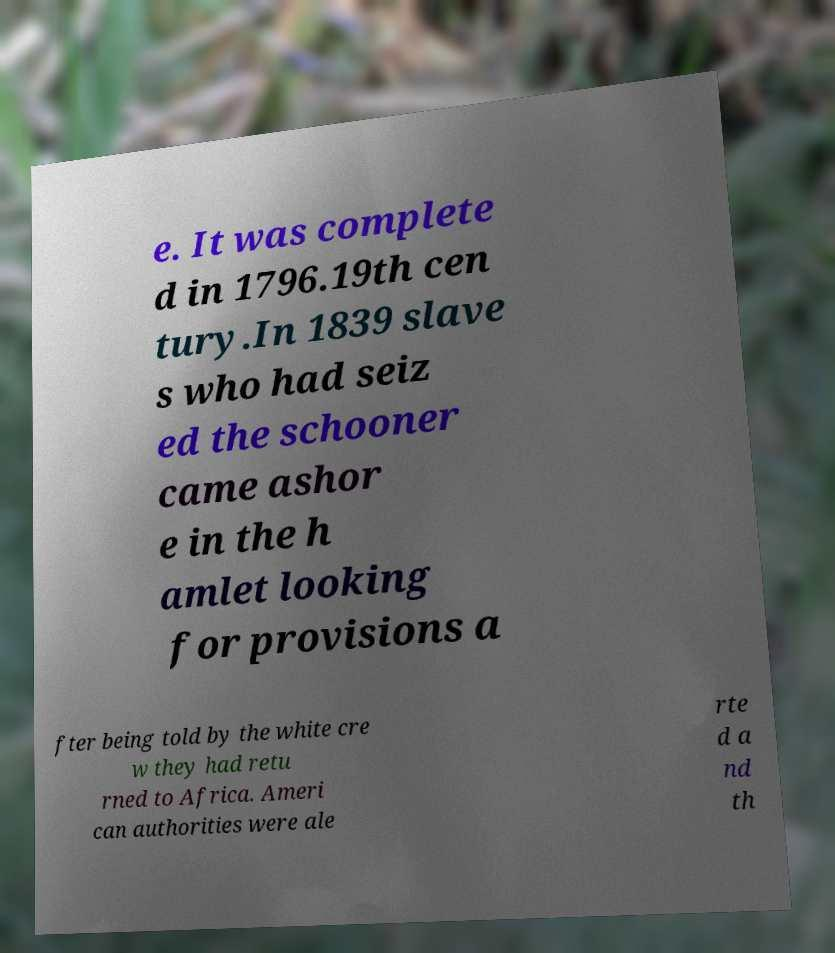Can you read and provide the text displayed in the image?This photo seems to have some interesting text. Can you extract and type it out for me? e. It was complete d in 1796.19th cen tury.In 1839 slave s who had seiz ed the schooner came ashor e in the h amlet looking for provisions a fter being told by the white cre w they had retu rned to Africa. Ameri can authorities were ale rte d a nd th 